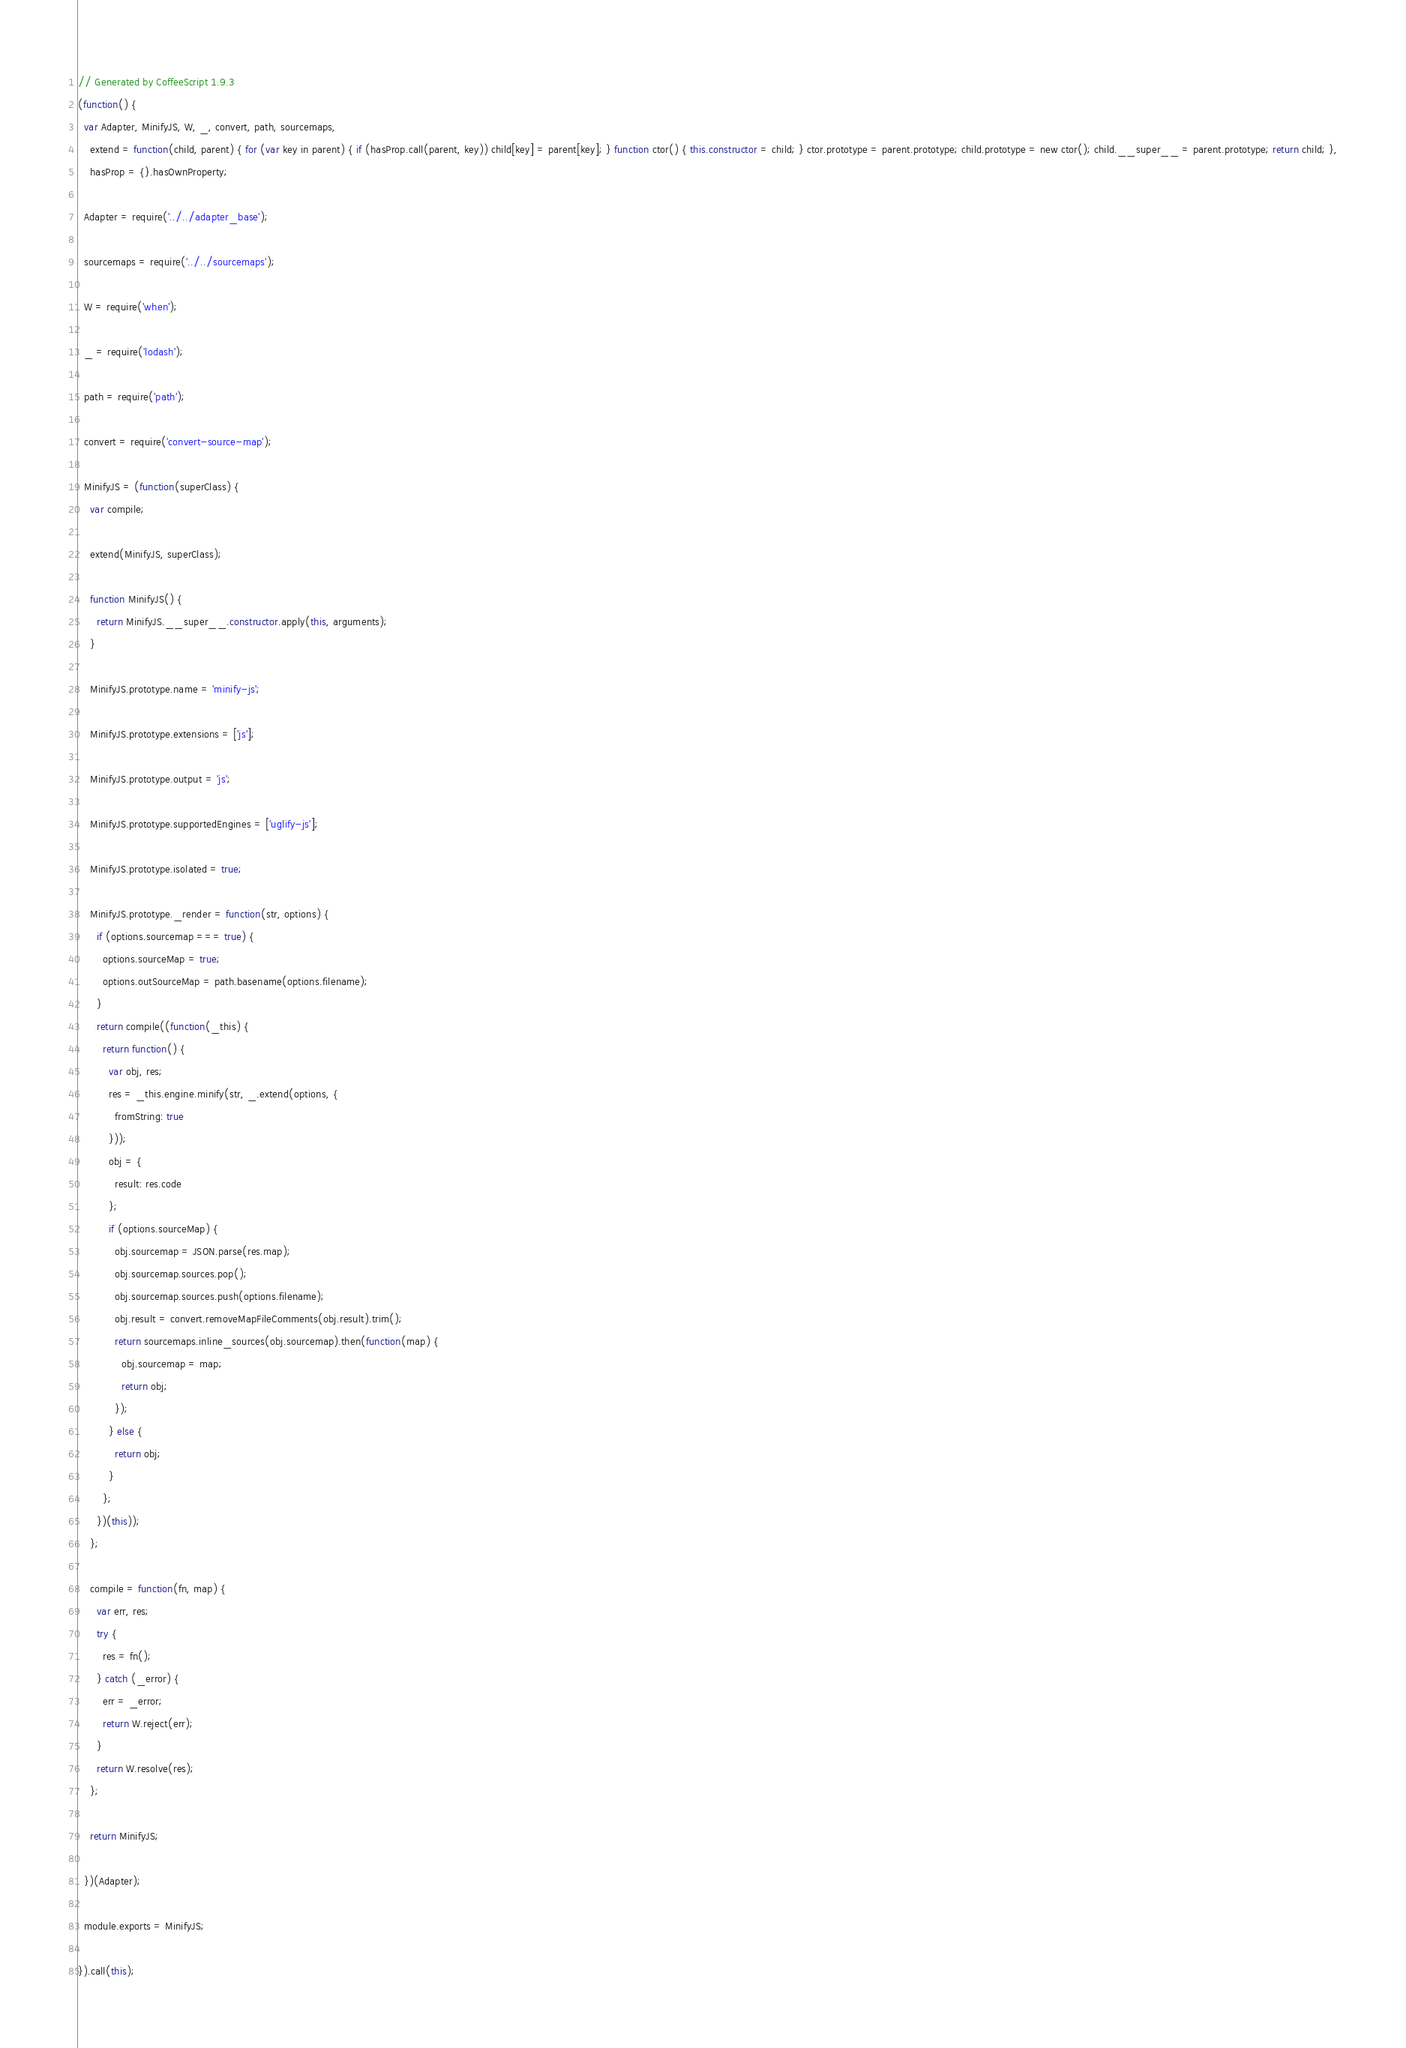<code> <loc_0><loc_0><loc_500><loc_500><_JavaScript_>// Generated by CoffeeScript 1.9.3
(function() {
  var Adapter, MinifyJS, W, _, convert, path, sourcemaps,
    extend = function(child, parent) { for (var key in parent) { if (hasProp.call(parent, key)) child[key] = parent[key]; } function ctor() { this.constructor = child; } ctor.prototype = parent.prototype; child.prototype = new ctor(); child.__super__ = parent.prototype; return child; },
    hasProp = {}.hasOwnProperty;

  Adapter = require('../../adapter_base');

  sourcemaps = require('../../sourcemaps');

  W = require('when');

  _ = require('lodash');

  path = require('path');

  convert = require('convert-source-map');

  MinifyJS = (function(superClass) {
    var compile;

    extend(MinifyJS, superClass);

    function MinifyJS() {
      return MinifyJS.__super__.constructor.apply(this, arguments);
    }

    MinifyJS.prototype.name = 'minify-js';

    MinifyJS.prototype.extensions = ['js'];

    MinifyJS.prototype.output = 'js';

    MinifyJS.prototype.supportedEngines = ['uglify-js'];

    MinifyJS.prototype.isolated = true;

    MinifyJS.prototype._render = function(str, options) {
      if (options.sourcemap === true) {
        options.sourceMap = true;
        options.outSourceMap = path.basename(options.filename);
      }
      return compile((function(_this) {
        return function() {
          var obj, res;
          res = _this.engine.minify(str, _.extend(options, {
            fromString: true
          }));
          obj = {
            result: res.code
          };
          if (options.sourceMap) {
            obj.sourcemap = JSON.parse(res.map);
            obj.sourcemap.sources.pop();
            obj.sourcemap.sources.push(options.filename);
            obj.result = convert.removeMapFileComments(obj.result).trim();
            return sourcemaps.inline_sources(obj.sourcemap).then(function(map) {
              obj.sourcemap = map;
              return obj;
            });
          } else {
            return obj;
          }
        };
      })(this));
    };

    compile = function(fn, map) {
      var err, res;
      try {
        res = fn();
      } catch (_error) {
        err = _error;
        return W.reject(err);
      }
      return W.resolve(res);
    };

    return MinifyJS;

  })(Adapter);

  module.exports = MinifyJS;

}).call(this);
</code> 